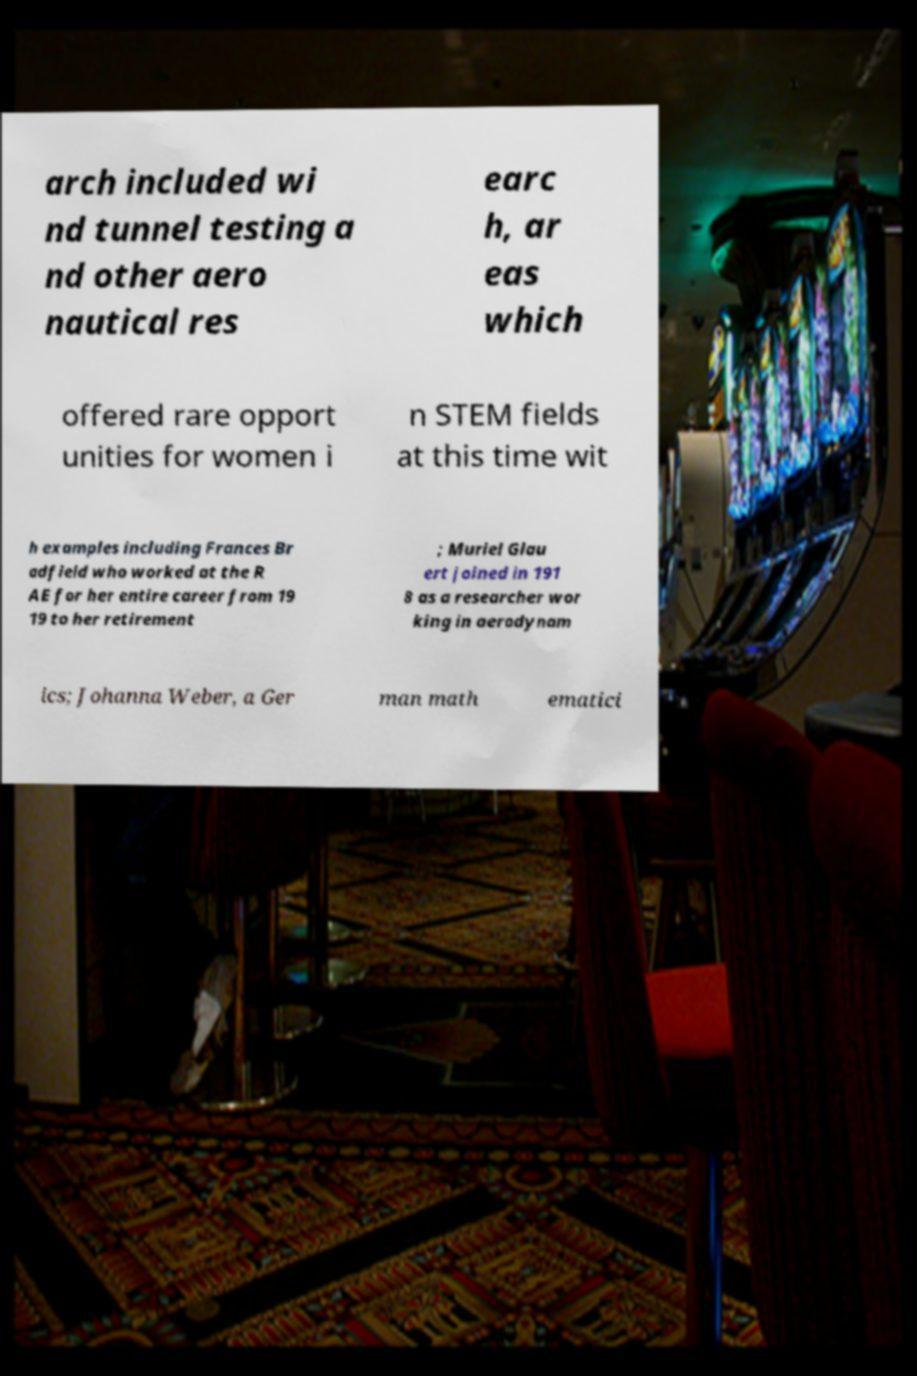I need the written content from this picture converted into text. Can you do that? arch included wi nd tunnel testing a nd other aero nautical res earc h, ar eas which offered rare opport unities for women i n STEM fields at this time wit h examples including Frances Br adfield who worked at the R AE for her entire career from 19 19 to her retirement ; Muriel Glau ert joined in 191 8 as a researcher wor king in aerodynam ics; Johanna Weber, a Ger man math ematici 